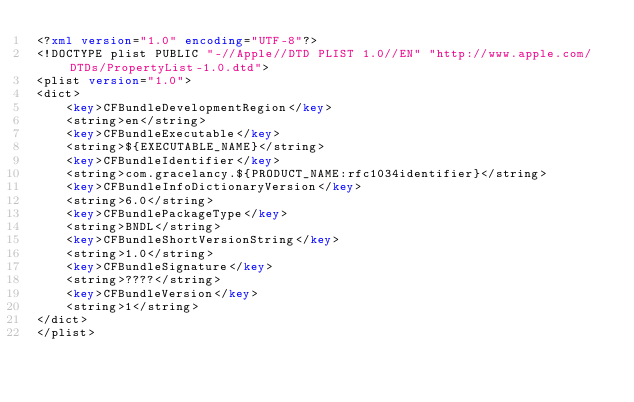<code> <loc_0><loc_0><loc_500><loc_500><_XML_><?xml version="1.0" encoding="UTF-8"?>
<!DOCTYPE plist PUBLIC "-//Apple//DTD PLIST 1.0//EN" "http://www.apple.com/DTDs/PropertyList-1.0.dtd">
<plist version="1.0">
<dict>
	<key>CFBundleDevelopmentRegion</key>
	<string>en</string>
	<key>CFBundleExecutable</key>
	<string>${EXECUTABLE_NAME}</string>
	<key>CFBundleIdentifier</key>
	<string>com.gracelancy.${PRODUCT_NAME:rfc1034identifier}</string>
	<key>CFBundleInfoDictionaryVersion</key>
	<string>6.0</string>
	<key>CFBundlePackageType</key>
	<string>BNDL</string>
	<key>CFBundleShortVersionString</key>
	<string>1.0</string>
	<key>CFBundleSignature</key>
	<string>????</string>
	<key>CFBundleVersion</key>
	<string>1</string>
</dict>
</plist>
</code> 